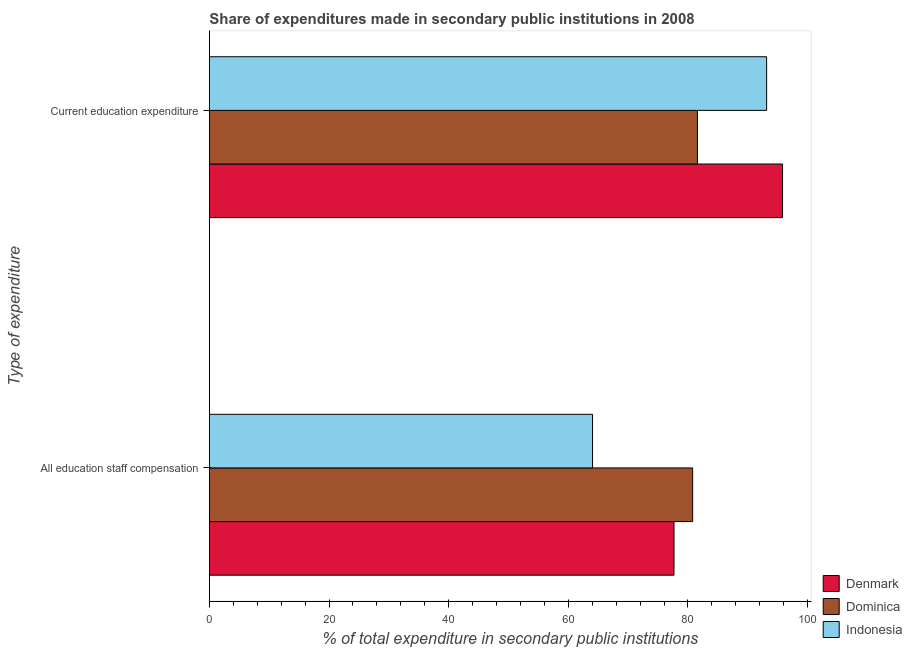How many groups of bars are there?
Your answer should be very brief. 2. Are the number of bars per tick equal to the number of legend labels?
Provide a short and direct response. Yes. How many bars are there on the 2nd tick from the top?
Ensure brevity in your answer.  3. What is the label of the 2nd group of bars from the top?
Ensure brevity in your answer.  All education staff compensation. What is the expenditure in education in Dominica?
Offer a terse response. 81.58. Across all countries, what is the maximum expenditure in staff compensation?
Make the answer very short. 80.78. Across all countries, what is the minimum expenditure in education?
Your response must be concise. 81.58. In which country was the expenditure in education maximum?
Ensure brevity in your answer.  Denmark. In which country was the expenditure in education minimum?
Keep it short and to the point. Dominica. What is the total expenditure in staff compensation in the graph?
Keep it short and to the point. 222.49. What is the difference between the expenditure in staff compensation in Denmark and that in Dominica?
Make the answer very short. -3.12. What is the difference between the expenditure in education in Indonesia and the expenditure in staff compensation in Dominica?
Offer a terse response. 12.36. What is the average expenditure in education per country?
Make the answer very short. 90.18. What is the difference between the expenditure in education and expenditure in staff compensation in Dominica?
Your response must be concise. 0.8. In how many countries, is the expenditure in education greater than 24 %?
Keep it short and to the point. 3. What is the ratio of the expenditure in staff compensation in Indonesia to that in Denmark?
Make the answer very short. 0.82. Is the expenditure in education in Denmark less than that in Dominica?
Keep it short and to the point. No. What does the 1st bar from the bottom in All education staff compensation represents?
Offer a terse response. Denmark. How many bars are there?
Keep it short and to the point. 6. What is the difference between two consecutive major ticks on the X-axis?
Make the answer very short. 20. Are the values on the major ticks of X-axis written in scientific E-notation?
Give a very brief answer. No. Does the graph contain grids?
Your answer should be compact. No. Where does the legend appear in the graph?
Ensure brevity in your answer.  Bottom right. How many legend labels are there?
Your answer should be very brief. 3. What is the title of the graph?
Your answer should be very brief. Share of expenditures made in secondary public institutions in 2008. What is the label or title of the X-axis?
Your answer should be compact. % of total expenditure in secondary public institutions. What is the label or title of the Y-axis?
Keep it short and to the point. Type of expenditure. What is the % of total expenditure in secondary public institutions in Denmark in All education staff compensation?
Give a very brief answer. 77.66. What is the % of total expenditure in secondary public institutions in Dominica in All education staff compensation?
Offer a terse response. 80.78. What is the % of total expenditure in secondary public institutions of Indonesia in All education staff compensation?
Make the answer very short. 64.04. What is the % of total expenditure in secondary public institutions of Denmark in Current education expenditure?
Your answer should be compact. 95.81. What is the % of total expenditure in secondary public institutions in Dominica in Current education expenditure?
Your answer should be compact. 81.58. What is the % of total expenditure in secondary public institutions of Indonesia in Current education expenditure?
Offer a terse response. 93.15. Across all Type of expenditure, what is the maximum % of total expenditure in secondary public institutions of Denmark?
Provide a succinct answer. 95.81. Across all Type of expenditure, what is the maximum % of total expenditure in secondary public institutions in Dominica?
Ensure brevity in your answer.  81.58. Across all Type of expenditure, what is the maximum % of total expenditure in secondary public institutions in Indonesia?
Your answer should be compact. 93.15. Across all Type of expenditure, what is the minimum % of total expenditure in secondary public institutions in Denmark?
Give a very brief answer. 77.66. Across all Type of expenditure, what is the minimum % of total expenditure in secondary public institutions in Dominica?
Give a very brief answer. 80.78. Across all Type of expenditure, what is the minimum % of total expenditure in secondary public institutions in Indonesia?
Make the answer very short. 64.04. What is the total % of total expenditure in secondary public institutions of Denmark in the graph?
Offer a terse response. 173.47. What is the total % of total expenditure in secondary public institutions in Dominica in the graph?
Provide a succinct answer. 162.36. What is the total % of total expenditure in secondary public institutions of Indonesia in the graph?
Offer a terse response. 157.19. What is the difference between the % of total expenditure in secondary public institutions of Denmark in All education staff compensation and that in Current education expenditure?
Offer a very short reply. -18.14. What is the difference between the % of total expenditure in secondary public institutions in Dominica in All education staff compensation and that in Current education expenditure?
Your answer should be very brief. -0.8. What is the difference between the % of total expenditure in secondary public institutions in Indonesia in All education staff compensation and that in Current education expenditure?
Offer a very short reply. -29.1. What is the difference between the % of total expenditure in secondary public institutions in Denmark in All education staff compensation and the % of total expenditure in secondary public institutions in Dominica in Current education expenditure?
Your answer should be very brief. -3.92. What is the difference between the % of total expenditure in secondary public institutions of Denmark in All education staff compensation and the % of total expenditure in secondary public institutions of Indonesia in Current education expenditure?
Give a very brief answer. -15.48. What is the difference between the % of total expenditure in secondary public institutions of Dominica in All education staff compensation and the % of total expenditure in secondary public institutions of Indonesia in Current education expenditure?
Your answer should be very brief. -12.36. What is the average % of total expenditure in secondary public institutions of Denmark per Type of expenditure?
Provide a succinct answer. 86.73. What is the average % of total expenditure in secondary public institutions in Dominica per Type of expenditure?
Your response must be concise. 81.18. What is the average % of total expenditure in secondary public institutions of Indonesia per Type of expenditure?
Provide a short and direct response. 78.59. What is the difference between the % of total expenditure in secondary public institutions in Denmark and % of total expenditure in secondary public institutions in Dominica in All education staff compensation?
Your answer should be very brief. -3.12. What is the difference between the % of total expenditure in secondary public institutions in Denmark and % of total expenditure in secondary public institutions in Indonesia in All education staff compensation?
Your answer should be very brief. 13.62. What is the difference between the % of total expenditure in secondary public institutions of Dominica and % of total expenditure in secondary public institutions of Indonesia in All education staff compensation?
Ensure brevity in your answer.  16.74. What is the difference between the % of total expenditure in secondary public institutions of Denmark and % of total expenditure in secondary public institutions of Dominica in Current education expenditure?
Give a very brief answer. 14.23. What is the difference between the % of total expenditure in secondary public institutions of Denmark and % of total expenditure in secondary public institutions of Indonesia in Current education expenditure?
Offer a very short reply. 2.66. What is the difference between the % of total expenditure in secondary public institutions in Dominica and % of total expenditure in secondary public institutions in Indonesia in Current education expenditure?
Your response must be concise. -11.57. What is the ratio of the % of total expenditure in secondary public institutions of Denmark in All education staff compensation to that in Current education expenditure?
Your answer should be very brief. 0.81. What is the ratio of the % of total expenditure in secondary public institutions in Dominica in All education staff compensation to that in Current education expenditure?
Make the answer very short. 0.99. What is the ratio of the % of total expenditure in secondary public institutions of Indonesia in All education staff compensation to that in Current education expenditure?
Give a very brief answer. 0.69. What is the difference between the highest and the second highest % of total expenditure in secondary public institutions in Denmark?
Make the answer very short. 18.14. What is the difference between the highest and the second highest % of total expenditure in secondary public institutions in Dominica?
Make the answer very short. 0.8. What is the difference between the highest and the second highest % of total expenditure in secondary public institutions in Indonesia?
Offer a very short reply. 29.1. What is the difference between the highest and the lowest % of total expenditure in secondary public institutions of Denmark?
Keep it short and to the point. 18.14. What is the difference between the highest and the lowest % of total expenditure in secondary public institutions of Dominica?
Give a very brief answer. 0.8. What is the difference between the highest and the lowest % of total expenditure in secondary public institutions of Indonesia?
Make the answer very short. 29.1. 